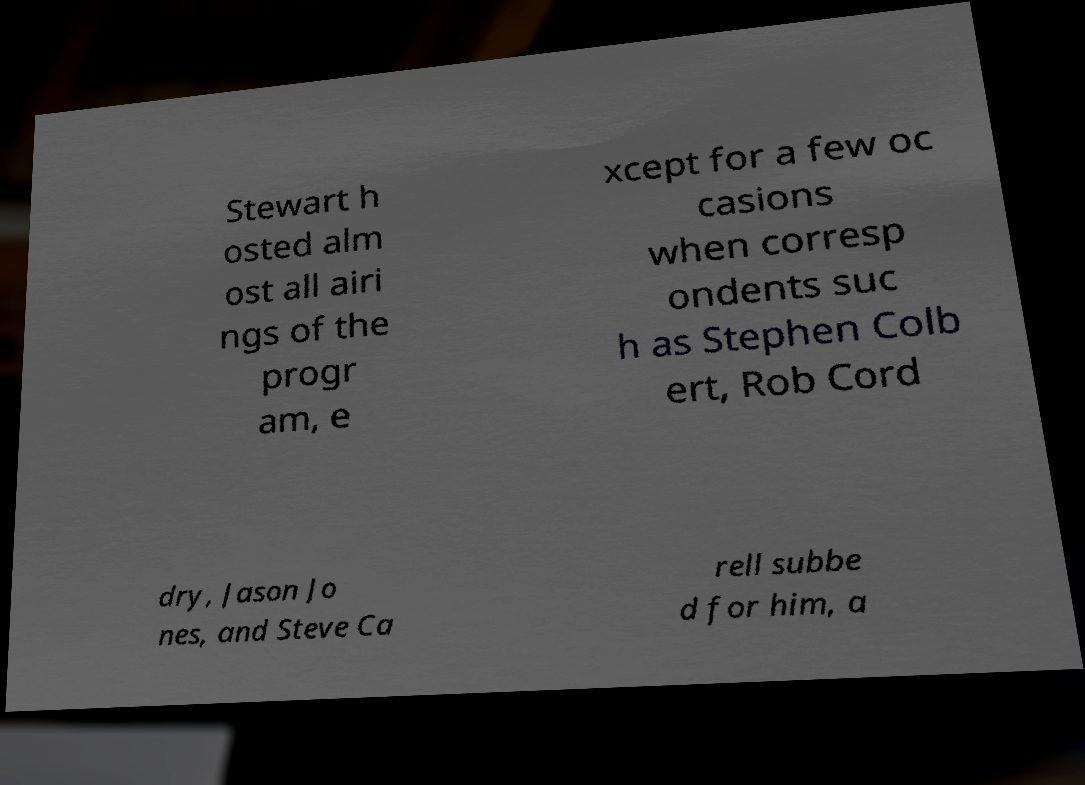What messages or text are displayed in this image? I need them in a readable, typed format. Stewart h osted alm ost all airi ngs of the progr am, e xcept for a few oc casions when corresp ondents suc h as Stephen Colb ert, Rob Cord dry, Jason Jo nes, and Steve Ca rell subbe d for him, a 